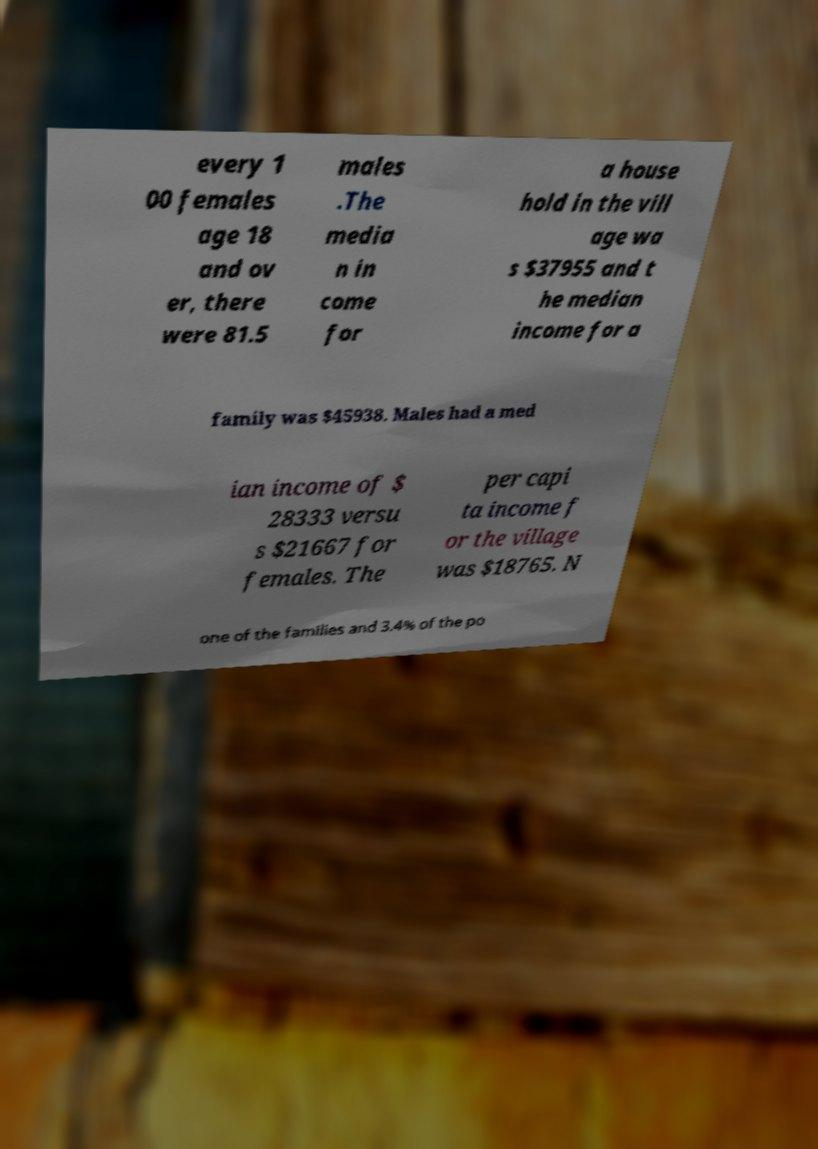There's text embedded in this image that I need extracted. Can you transcribe it verbatim? every 1 00 females age 18 and ov er, there were 81.5 males .The media n in come for a house hold in the vill age wa s $37955 and t he median income for a family was $45938. Males had a med ian income of $ 28333 versu s $21667 for females. The per capi ta income f or the village was $18765. N one of the families and 3.4% of the po 